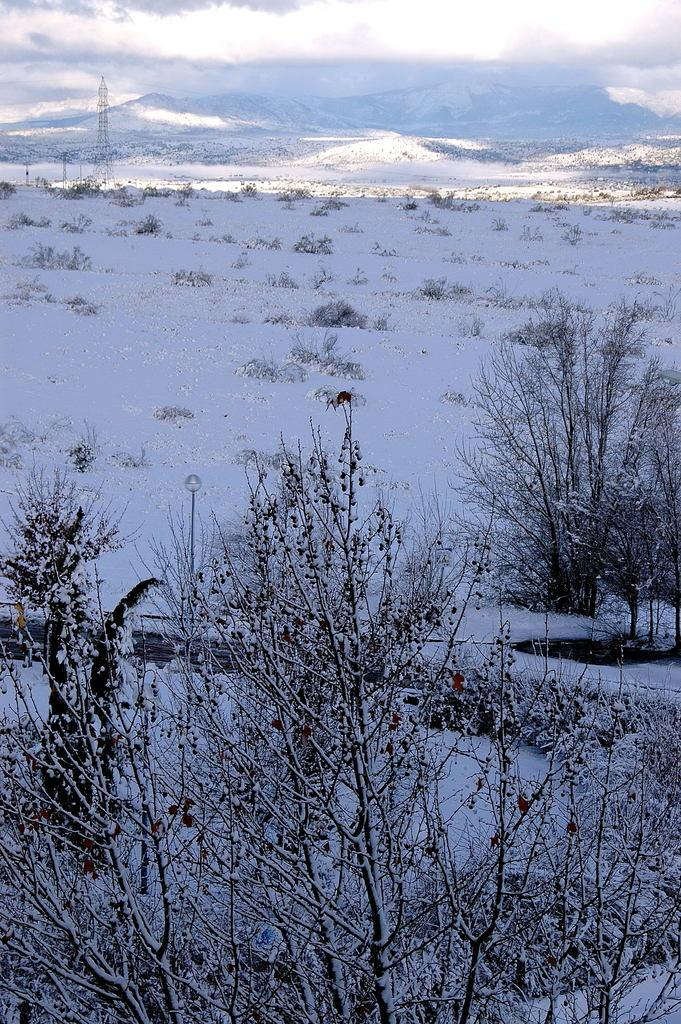What is the primary weather condition depicted in the image? There is snow in the image. What type of vegetation can be seen in the image? There are plants in the image. What can be seen in the background of the image? There is a tower and hills in the background of the image. What type of sofa can be seen in the image? There is no sofa present in the image. Is there a scarf tied in a knot on any of the plants in the image? There is no scarf or knot present in the image. 